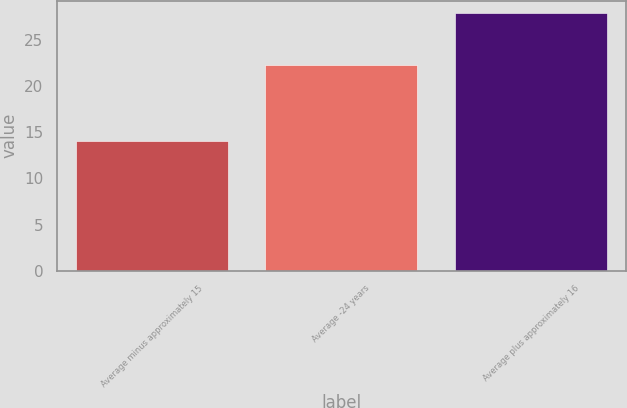Convert chart. <chart><loc_0><loc_0><loc_500><loc_500><bar_chart><fcel>Average minus approximately 15<fcel>Average -24 years<fcel>Average plus approximately 16<nl><fcel>14.1<fcel>22.3<fcel>27.9<nl></chart> 